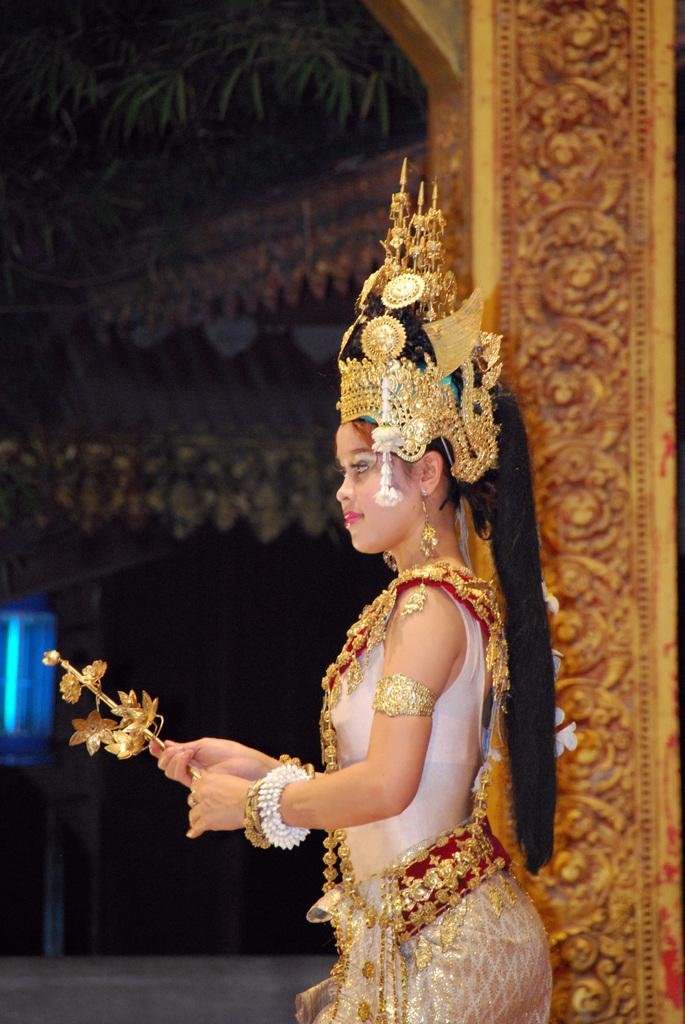Who is the main subject in the image? There is a woman in the image. What is the woman doing in the image? The woman is standing. What is the woman wearing in the image? The woman is wearing ornaments and a white color dress. What type of unit can be seen in the woman's hand in the image? There is no unit visible in the woman's hand in the image. 